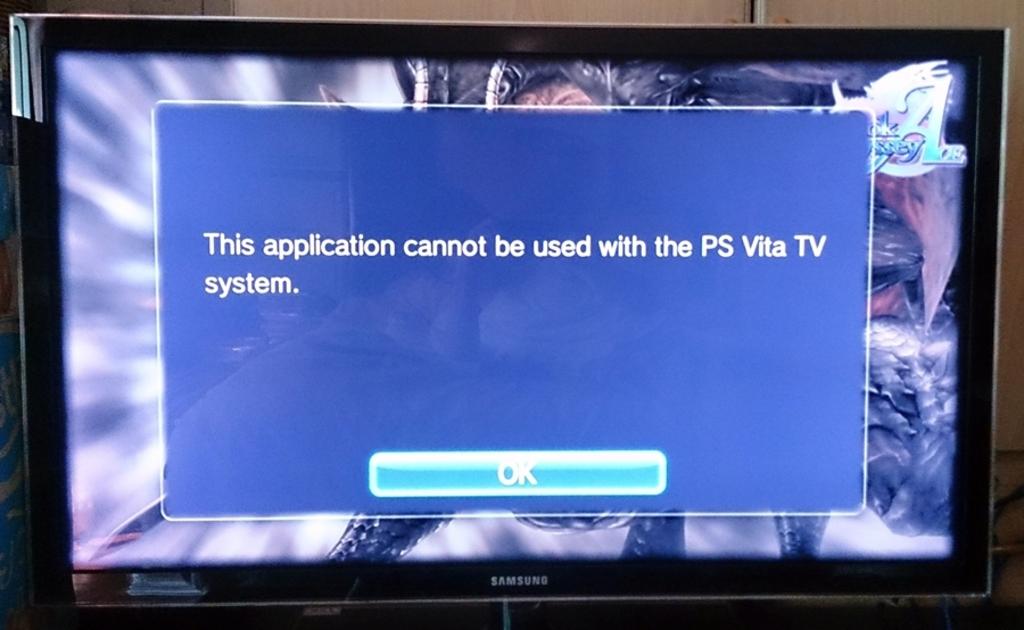What is the brand of the tv?
Offer a terse response. Samsung. What system is being use on the tv?
Make the answer very short. Ps vita. 